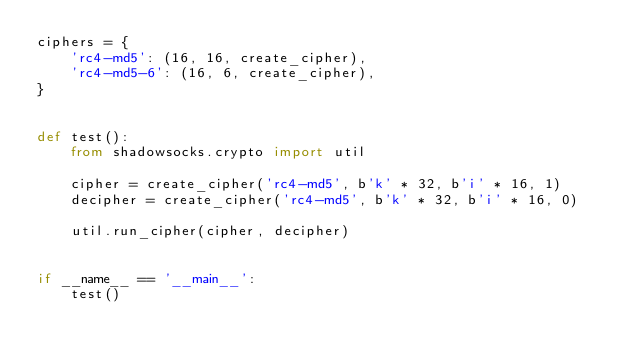<code> <loc_0><loc_0><loc_500><loc_500><_Python_>ciphers = {
    'rc4-md5': (16, 16, create_cipher),
    'rc4-md5-6': (16, 6, create_cipher),
}


def test():
    from shadowsocks.crypto import util

    cipher = create_cipher('rc4-md5', b'k' * 32, b'i' * 16, 1)
    decipher = create_cipher('rc4-md5', b'k' * 32, b'i' * 16, 0)

    util.run_cipher(cipher, decipher)


if __name__ == '__main__':
    test()
</code> 